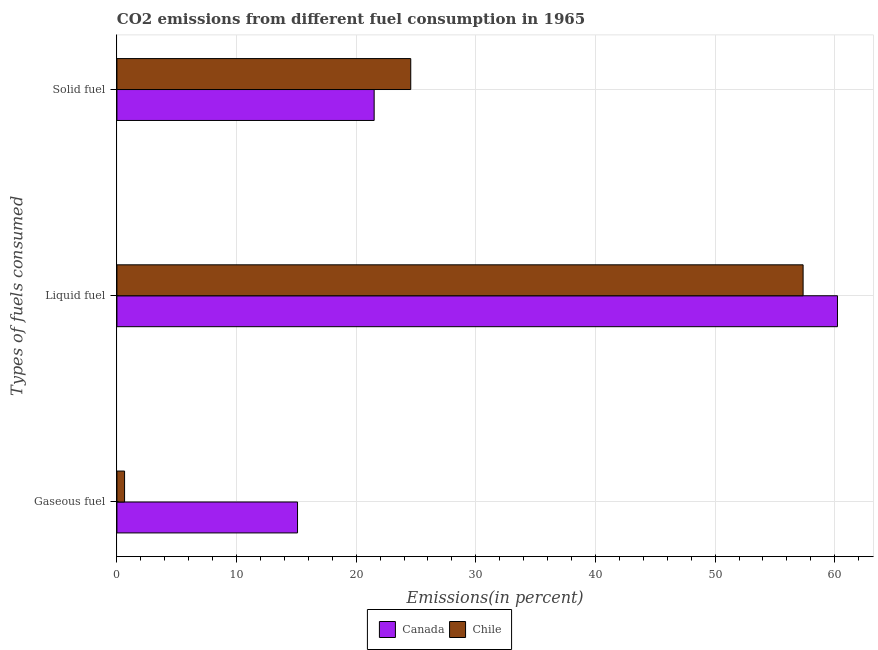How many different coloured bars are there?
Offer a terse response. 2. How many groups of bars are there?
Provide a short and direct response. 3. How many bars are there on the 3rd tick from the top?
Give a very brief answer. 2. How many bars are there on the 2nd tick from the bottom?
Give a very brief answer. 2. What is the label of the 2nd group of bars from the top?
Your answer should be very brief. Liquid fuel. What is the percentage of solid fuel emission in Chile?
Your answer should be compact. 24.56. Across all countries, what is the maximum percentage of solid fuel emission?
Your response must be concise. 24.56. Across all countries, what is the minimum percentage of gaseous fuel emission?
Offer a very short reply. 0.64. What is the total percentage of gaseous fuel emission in the graph?
Offer a terse response. 15.74. What is the difference between the percentage of solid fuel emission in Chile and that in Canada?
Provide a short and direct response. 3.06. What is the difference between the percentage of liquid fuel emission in Chile and the percentage of gaseous fuel emission in Canada?
Provide a short and direct response. 42.26. What is the average percentage of solid fuel emission per country?
Offer a terse response. 23.03. What is the difference between the percentage of solid fuel emission and percentage of liquid fuel emission in Canada?
Your answer should be compact. -38.73. What is the ratio of the percentage of solid fuel emission in Chile to that in Canada?
Your answer should be very brief. 1.14. Is the percentage of liquid fuel emission in Canada less than that in Chile?
Provide a short and direct response. No. Is the difference between the percentage of gaseous fuel emission in Canada and Chile greater than the difference between the percentage of liquid fuel emission in Canada and Chile?
Your answer should be compact. Yes. What is the difference between the highest and the second highest percentage of liquid fuel emission?
Your response must be concise. 2.87. What is the difference between the highest and the lowest percentage of liquid fuel emission?
Keep it short and to the point. 2.87. In how many countries, is the percentage of gaseous fuel emission greater than the average percentage of gaseous fuel emission taken over all countries?
Your response must be concise. 1. What does the 2nd bar from the bottom in Solid fuel represents?
Keep it short and to the point. Chile. Is it the case that in every country, the sum of the percentage of gaseous fuel emission and percentage of liquid fuel emission is greater than the percentage of solid fuel emission?
Offer a very short reply. Yes. How many bars are there?
Offer a terse response. 6. How many countries are there in the graph?
Your response must be concise. 2. Are the values on the major ticks of X-axis written in scientific E-notation?
Offer a terse response. No. How many legend labels are there?
Give a very brief answer. 2. How are the legend labels stacked?
Provide a succinct answer. Horizontal. What is the title of the graph?
Your response must be concise. CO2 emissions from different fuel consumption in 1965. Does "Bangladesh" appear as one of the legend labels in the graph?
Provide a succinct answer. No. What is the label or title of the X-axis?
Provide a short and direct response. Emissions(in percent). What is the label or title of the Y-axis?
Your response must be concise. Types of fuels consumed. What is the Emissions(in percent) of Canada in Gaseous fuel?
Your response must be concise. 15.1. What is the Emissions(in percent) of Chile in Gaseous fuel?
Make the answer very short. 0.64. What is the Emissions(in percent) of Canada in Liquid fuel?
Offer a very short reply. 60.23. What is the Emissions(in percent) in Chile in Liquid fuel?
Keep it short and to the point. 57.36. What is the Emissions(in percent) of Canada in Solid fuel?
Your answer should be compact. 21.5. What is the Emissions(in percent) in Chile in Solid fuel?
Provide a short and direct response. 24.56. Across all Types of fuels consumed, what is the maximum Emissions(in percent) of Canada?
Make the answer very short. 60.23. Across all Types of fuels consumed, what is the maximum Emissions(in percent) of Chile?
Ensure brevity in your answer.  57.36. Across all Types of fuels consumed, what is the minimum Emissions(in percent) of Canada?
Your answer should be compact. 15.1. Across all Types of fuels consumed, what is the minimum Emissions(in percent) of Chile?
Make the answer very short. 0.64. What is the total Emissions(in percent) in Canada in the graph?
Offer a very short reply. 96.83. What is the total Emissions(in percent) of Chile in the graph?
Your answer should be compact. 82.56. What is the difference between the Emissions(in percent) in Canada in Gaseous fuel and that in Liquid fuel?
Keep it short and to the point. -45.13. What is the difference between the Emissions(in percent) of Chile in Gaseous fuel and that in Liquid fuel?
Keep it short and to the point. -56.72. What is the difference between the Emissions(in percent) in Canada in Gaseous fuel and that in Solid fuel?
Offer a very short reply. -6.41. What is the difference between the Emissions(in percent) of Chile in Gaseous fuel and that in Solid fuel?
Keep it short and to the point. -23.92. What is the difference between the Emissions(in percent) in Canada in Liquid fuel and that in Solid fuel?
Offer a terse response. 38.73. What is the difference between the Emissions(in percent) of Chile in Liquid fuel and that in Solid fuel?
Your answer should be compact. 32.8. What is the difference between the Emissions(in percent) of Canada in Gaseous fuel and the Emissions(in percent) of Chile in Liquid fuel?
Give a very brief answer. -42.26. What is the difference between the Emissions(in percent) of Canada in Gaseous fuel and the Emissions(in percent) of Chile in Solid fuel?
Offer a terse response. -9.46. What is the difference between the Emissions(in percent) in Canada in Liquid fuel and the Emissions(in percent) in Chile in Solid fuel?
Your answer should be very brief. 35.67. What is the average Emissions(in percent) in Canada per Types of fuels consumed?
Ensure brevity in your answer.  32.28. What is the average Emissions(in percent) in Chile per Types of fuels consumed?
Your answer should be compact. 27.52. What is the difference between the Emissions(in percent) in Canada and Emissions(in percent) in Chile in Gaseous fuel?
Offer a terse response. 14.46. What is the difference between the Emissions(in percent) of Canada and Emissions(in percent) of Chile in Liquid fuel?
Your answer should be very brief. 2.87. What is the difference between the Emissions(in percent) of Canada and Emissions(in percent) of Chile in Solid fuel?
Your response must be concise. -3.06. What is the ratio of the Emissions(in percent) of Canada in Gaseous fuel to that in Liquid fuel?
Ensure brevity in your answer.  0.25. What is the ratio of the Emissions(in percent) in Chile in Gaseous fuel to that in Liquid fuel?
Provide a succinct answer. 0.01. What is the ratio of the Emissions(in percent) of Canada in Gaseous fuel to that in Solid fuel?
Provide a succinct answer. 0.7. What is the ratio of the Emissions(in percent) of Chile in Gaseous fuel to that in Solid fuel?
Offer a very short reply. 0.03. What is the ratio of the Emissions(in percent) in Canada in Liquid fuel to that in Solid fuel?
Give a very brief answer. 2.8. What is the ratio of the Emissions(in percent) in Chile in Liquid fuel to that in Solid fuel?
Give a very brief answer. 2.34. What is the difference between the highest and the second highest Emissions(in percent) in Canada?
Offer a very short reply. 38.73. What is the difference between the highest and the second highest Emissions(in percent) of Chile?
Your answer should be compact. 32.8. What is the difference between the highest and the lowest Emissions(in percent) of Canada?
Your answer should be very brief. 45.13. What is the difference between the highest and the lowest Emissions(in percent) in Chile?
Offer a terse response. 56.72. 